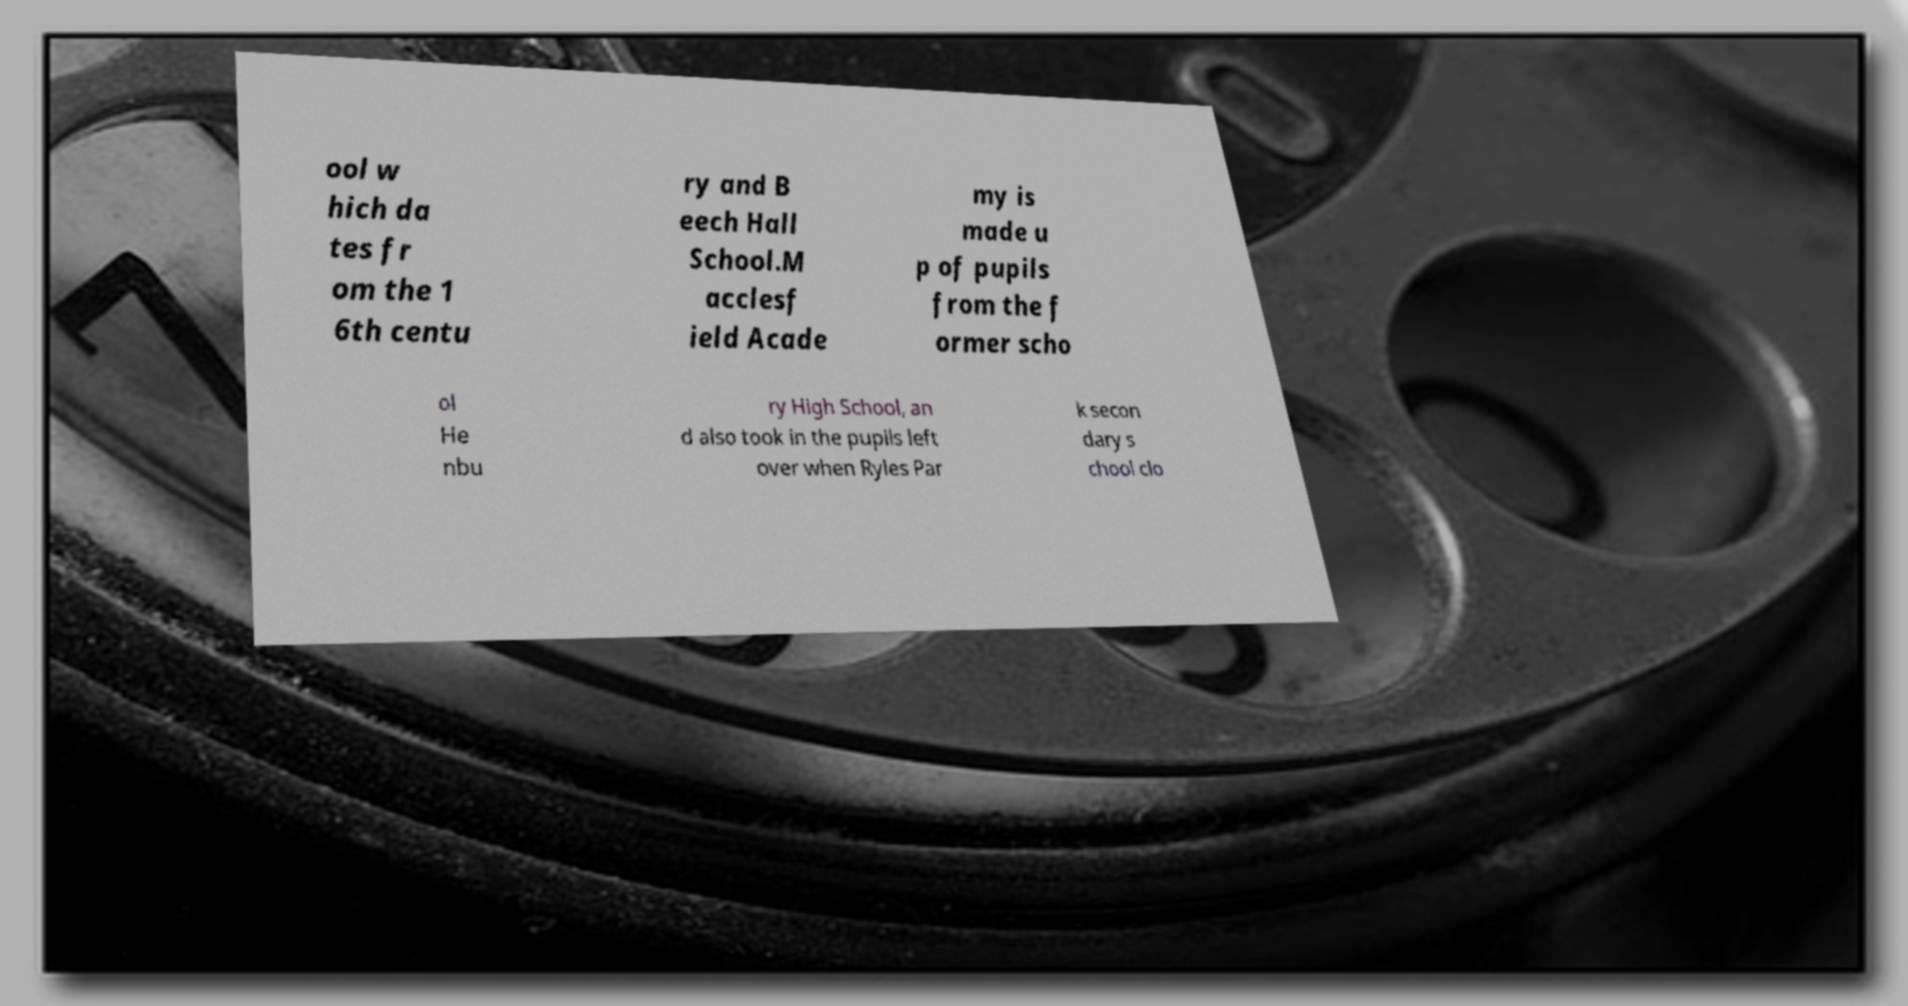I need the written content from this picture converted into text. Can you do that? ool w hich da tes fr om the 1 6th centu ry and B eech Hall School.M acclesf ield Acade my is made u p of pupils from the f ormer scho ol He nbu ry High School, an d also took in the pupils left over when Ryles Par k secon dary s chool clo 